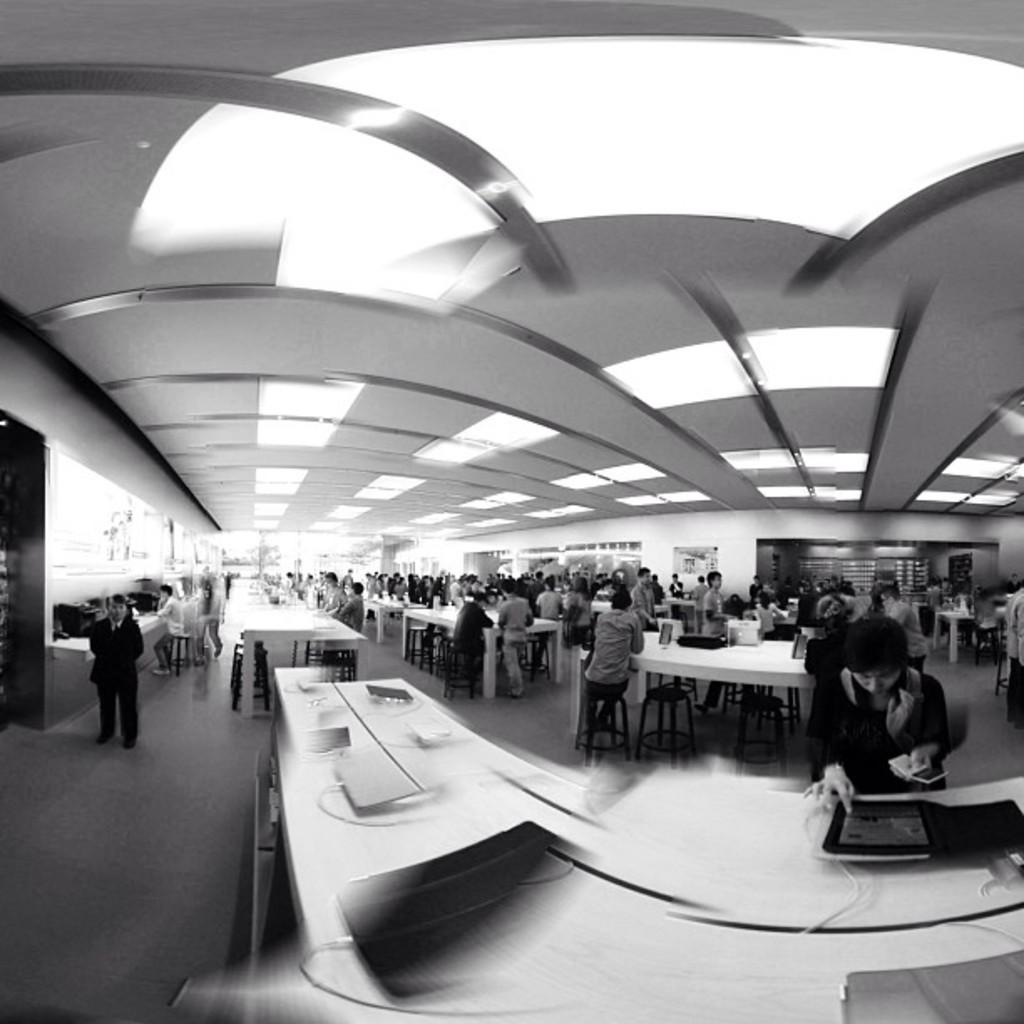What are the people in the image doing? There is a group of people on the floor in the image. What type of furniture can be seen in the image? There are tables and stools in the image. What objects are visible in the image? There are objects visible in the image, but their specific nature is not mentioned in the facts. What can be seen in the background of the image? There is a wall and a roof in the background of the image. What type of statement is being made by the cakes on the tables in the image? There are no cakes present in the image, so it is not possible to answer that question. 